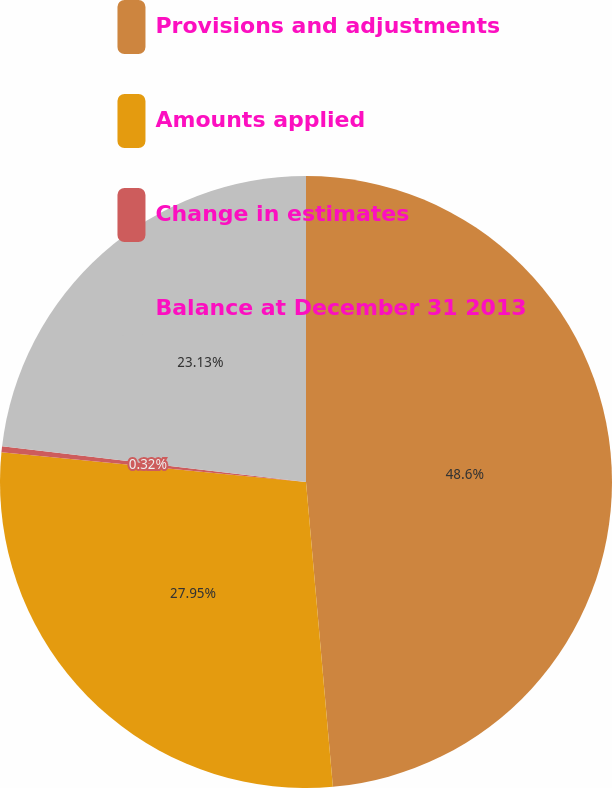<chart> <loc_0><loc_0><loc_500><loc_500><pie_chart><fcel>Provisions and adjustments<fcel>Amounts applied<fcel>Change in estimates<fcel>Balance at December 31 2013<nl><fcel>48.6%<fcel>27.95%<fcel>0.32%<fcel>23.13%<nl></chart> 